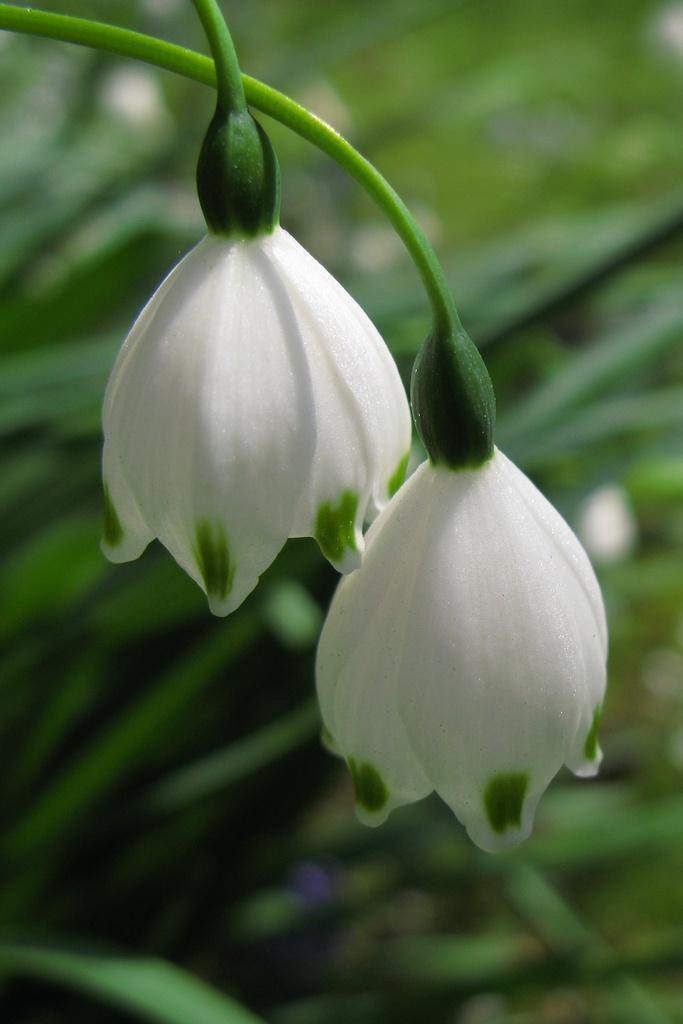Describe this image in one or two sentences. In this image we can see the flowers to the stems of a plant. 